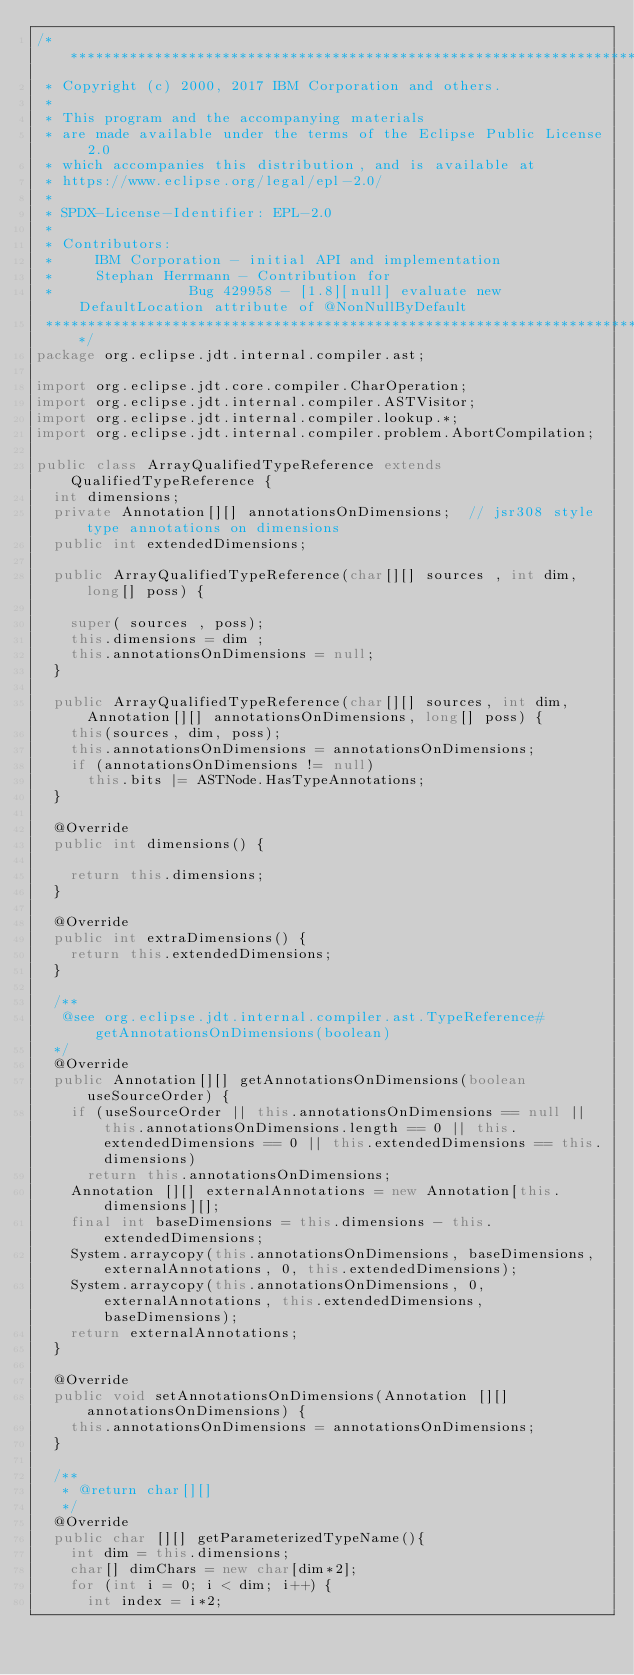<code> <loc_0><loc_0><loc_500><loc_500><_Java_>/*******************************************************************************
 * Copyright (c) 2000, 2017 IBM Corporation and others.
 *
 * This program and the accompanying materials
 * are made available under the terms of the Eclipse Public License 2.0
 * which accompanies this distribution, and is available at
 * https://www.eclipse.org/legal/epl-2.0/
 *
 * SPDX-License-Identifier: EPL-2.0
 *
 * Contributors:
 *     IBM Corporation - initial API and implementation
 *     Stephan Herrmann - Contribution for
 *								Bug 429958 - [1.8][null] evaluate new DefaultLocation attribute of @NonNullByDefault
 *******************************************************************************/
package org.eclipse.jdt.internal.compiler.ast;

import org.eclipse.jdt.core.compiler.CharOperation;
import org.eclipse.jdt.internal.compiler.ASTVisitor;
import org.eclipse.jdt.internal.compiler.lookup.*;
import org.eclipse.jdt.internal.compiler.problem.AbortCompilation;

public class ArrayQualifiedTypeReference extends QualifiedTypeReference {
	int dimensions;
	private Annotation[][] annotationsOnDimensions;  // jsr308 style type annotations on dimensions
	public int extendedDimensions;

	public ArrayQualifiedTypeReference(char[][] sources , int dim, long[] poss) {

		super( sources , poss);
		this.dimensions = dim ;
		this.annotationsOnDimensions = null;
	}

	public ArrayQualifiedTypeReference(char[][] sources, int dim, Annotation[][] annotationsOnDimensions, long[] poss) {
		this(sources, dim, poss);
		this.annotationsOnDimensions = annotationsOnDimensions;
		if (annotationsOnDimensions != null)
			this.bits |= ASTNode.HasTypeAnnotations;
	}

	@Override
	public int dimensions() {

		return this.dimensions;
	}

	@Override
	public int extraDimensions() {
		return this.extendedDimensions;
	}

	/**
	 @see org.eclipse.jdt.internal.compiler.ast.TypeReference#getAnnotationsOnDimensions(boolean)
	*/
	@Override
	public Annotation[][] getAnnotationsOnDimensions(boolean useSourceOrder) {
		if (useSourceOrder || this.annotationsOnDimensions == null || this.annotationsOnDimensions.length == 0 || this.extendedDimensions == 0 || this.extendedDimensions == this.dimensions)
			return this.annotationsOnDimensions;
		Annotation [][] externalAnnotations = new Annotation[this.dimensions][];
		final int baseDimensions = this.dimensions - this.extendedDimensions;
		System.arraycopy(this.annotationsOnDimensions, baseDimensions, externalAnnotations, 0, this.extendedDimensions);
		System.arraycopy(this.annotationsOnDimensions, 0, externalAnnotations, this.extendedDimensions, baseDimensions);
		return externalAnnotations;
	}

	@Override
	public void setAnnotationsOnDimensions(Annotation [][] annotationsOnDimensions) {
		this.annotationsOnDimensions = annotationsOnDimensions;
	}

	/**
	 * @return char[][]
	 */
	@Override
	public char [][] getParameterizedTypeName(){
		int dim = this.dimensions;
		char[] dimChars = new char[dim*2];
		for (int i = 0; i < dim; i++) {
			int index = i*2;</code> 